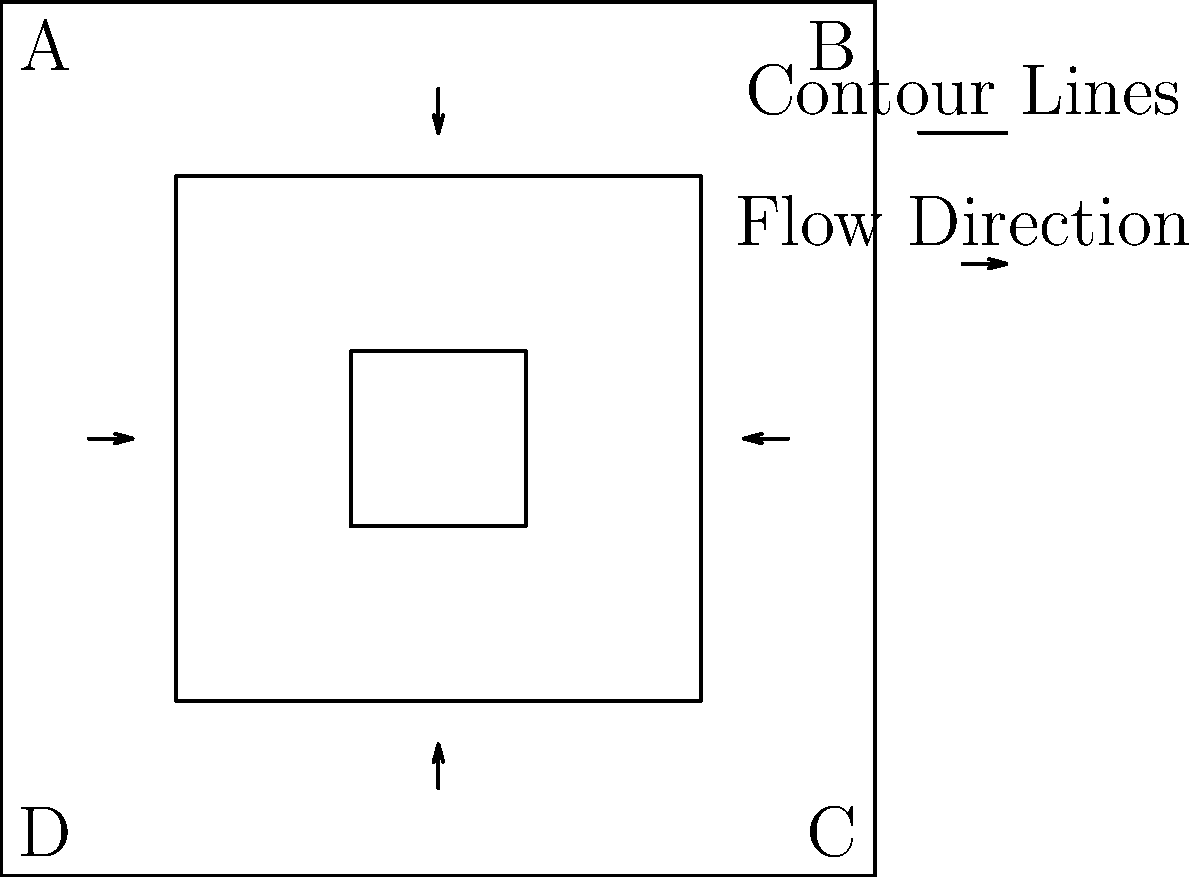Based on the topographic map and flow direction arrows shown, which point (A, B, C, or D) is most likely to experience flooding during heavy rainfall? Explain your reasoning considering the elevation contours and flow directions. To determine the point most likely to experience flooding, we need to analyze the topographic map and flow direction arrows:

1. Interpret the contour lines:
   - The outermost contour represents the lowest elevation.
   - The innermost contour represents the highest elevation.
   - The area is bowl-shaped with higher elevation in the center.

2. Analyze flow directions:
   - Arrows indicate water flow from higher to lower elevations.
   - Water flows inward from all sides towards the center.

3. Assess each point:
   - Point A: Located at a corner of the lowest contour.
   - Point B: Located at a corner of the lowest contour.
   - Point C: Located at a corner of the lowest contour.
   - Point D: Located at a corner of the lowest contour.

4. Consider the combined effect:
   - All points are at the same elevation (lowest contour).
   - Water flows towards the center, away from all corner points.
   - However, Point D is where two inward flows converge.

5. Conclusion:
   Point D is most likely to experience flooding because:
   - It's at the lowest elevation.
   - It's where two flow directions meet, potentially accumulating more water.
   - The converging flows may cause water to pool in this area.
Answer: Point D 